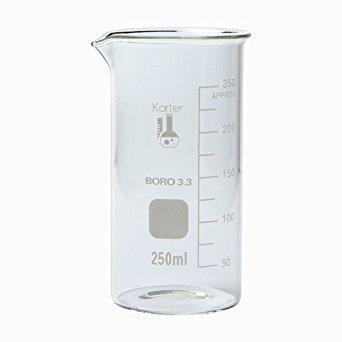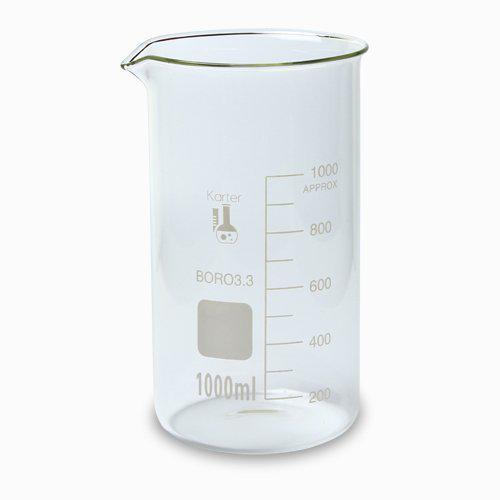The first image is the image on the left, the second image is the image on the right. For the images displayed, is the sentence "There are at most two beakers." factually correct? Answer yes or no. Yes. The first image is the image on the left, the second image is the image on the right. For the images displayed, is the sentence "All of the measuring containers appear to be empty of liquid." factually correct? Answer yes or no. Yes. 